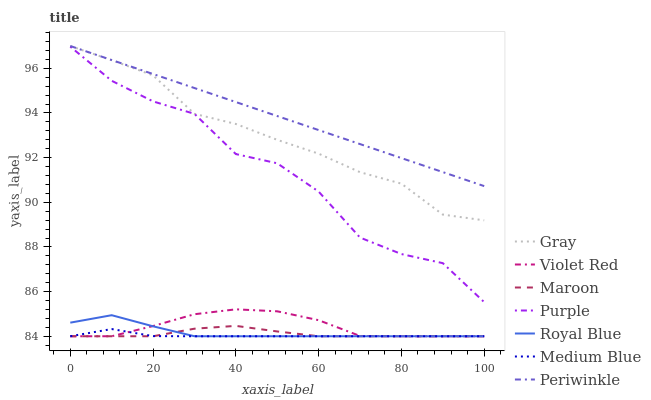Does Medium Blue have the minimum area under the curve?
Answer yes or no. Yes. Does Periwinkle have the maximum area under the curve?
Answer yes or no. Yes. Does Violet Red have the minimum area under the curve?
Answer yes or no. No. Does Violet Red have the maximum area under the curve?
Answer yes or no. No. Is Periwinkle the smoothest?
Answer yes or no. Yes. Is Purple the roughest?
Answer yes or no. Yes. Is Violet Red the smoothest?
Answer yes or no. No. Is Violet Red the roughest?
Answer yes or no. No. Does Purple have the lowest value?
Answer yes or no. No. Does Periwinkle have the highest value?
Answer yes or no. Yes. Does Violet Red have the highest value?
Answer yes or no. No. Is Medium Blue less than Gray?
Answer yes or no. Yes. Is Gray greater than Purple?
Answer yes or no. Yes. Does Maroon intersect Medium Blue?
Answer yes or no. Yes. Is Maroon less than Medium Blue?
Answer yes or no. No. Is Maroon greater than Medium Blue?
Answer yes or no. No. Does Medium Blue intersect Gray?
Answer yes or no. No. 